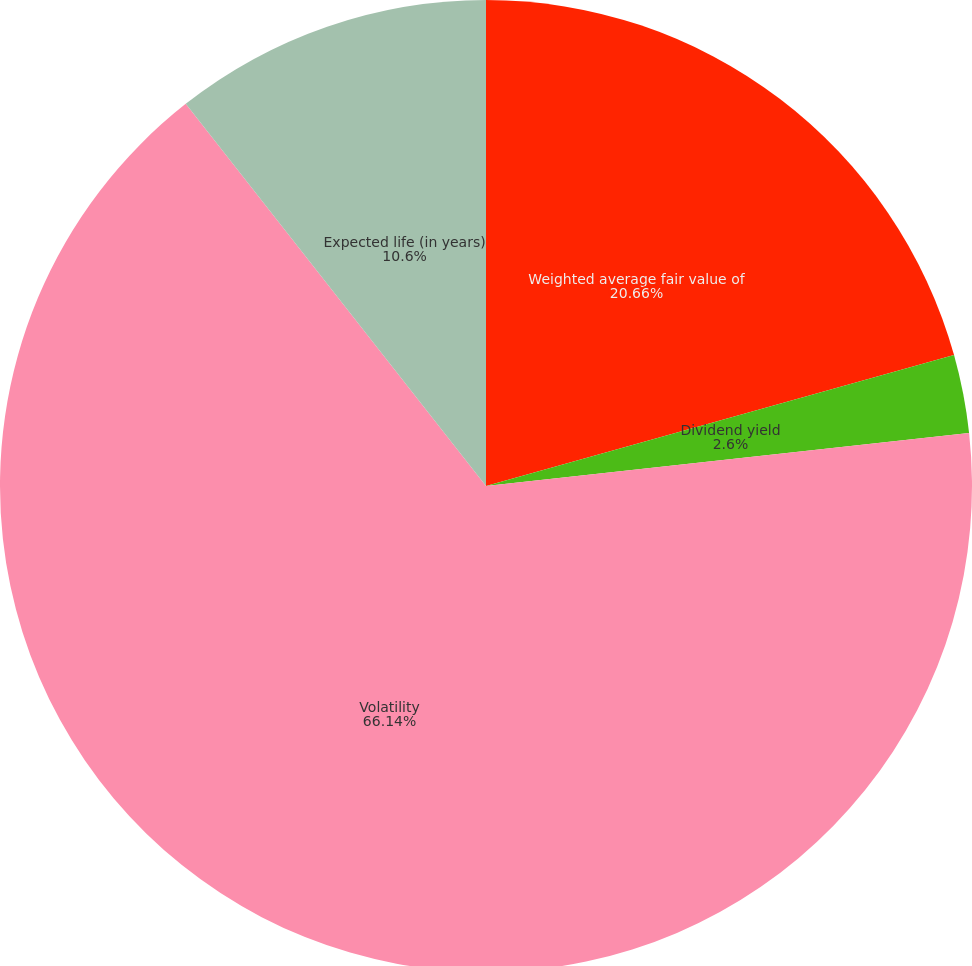<chart> <loc_0><loc_0><loc_500><loc_500><pie_chart><fcel>Weighted average fair value of<fcel>Dividend yield<fcel>Volatility<fcel>Expected life (in years)<nl><fcel>20.66%<fcel>2.6%<fcel>66.14%<fcel>10.6%<nl></chart> 